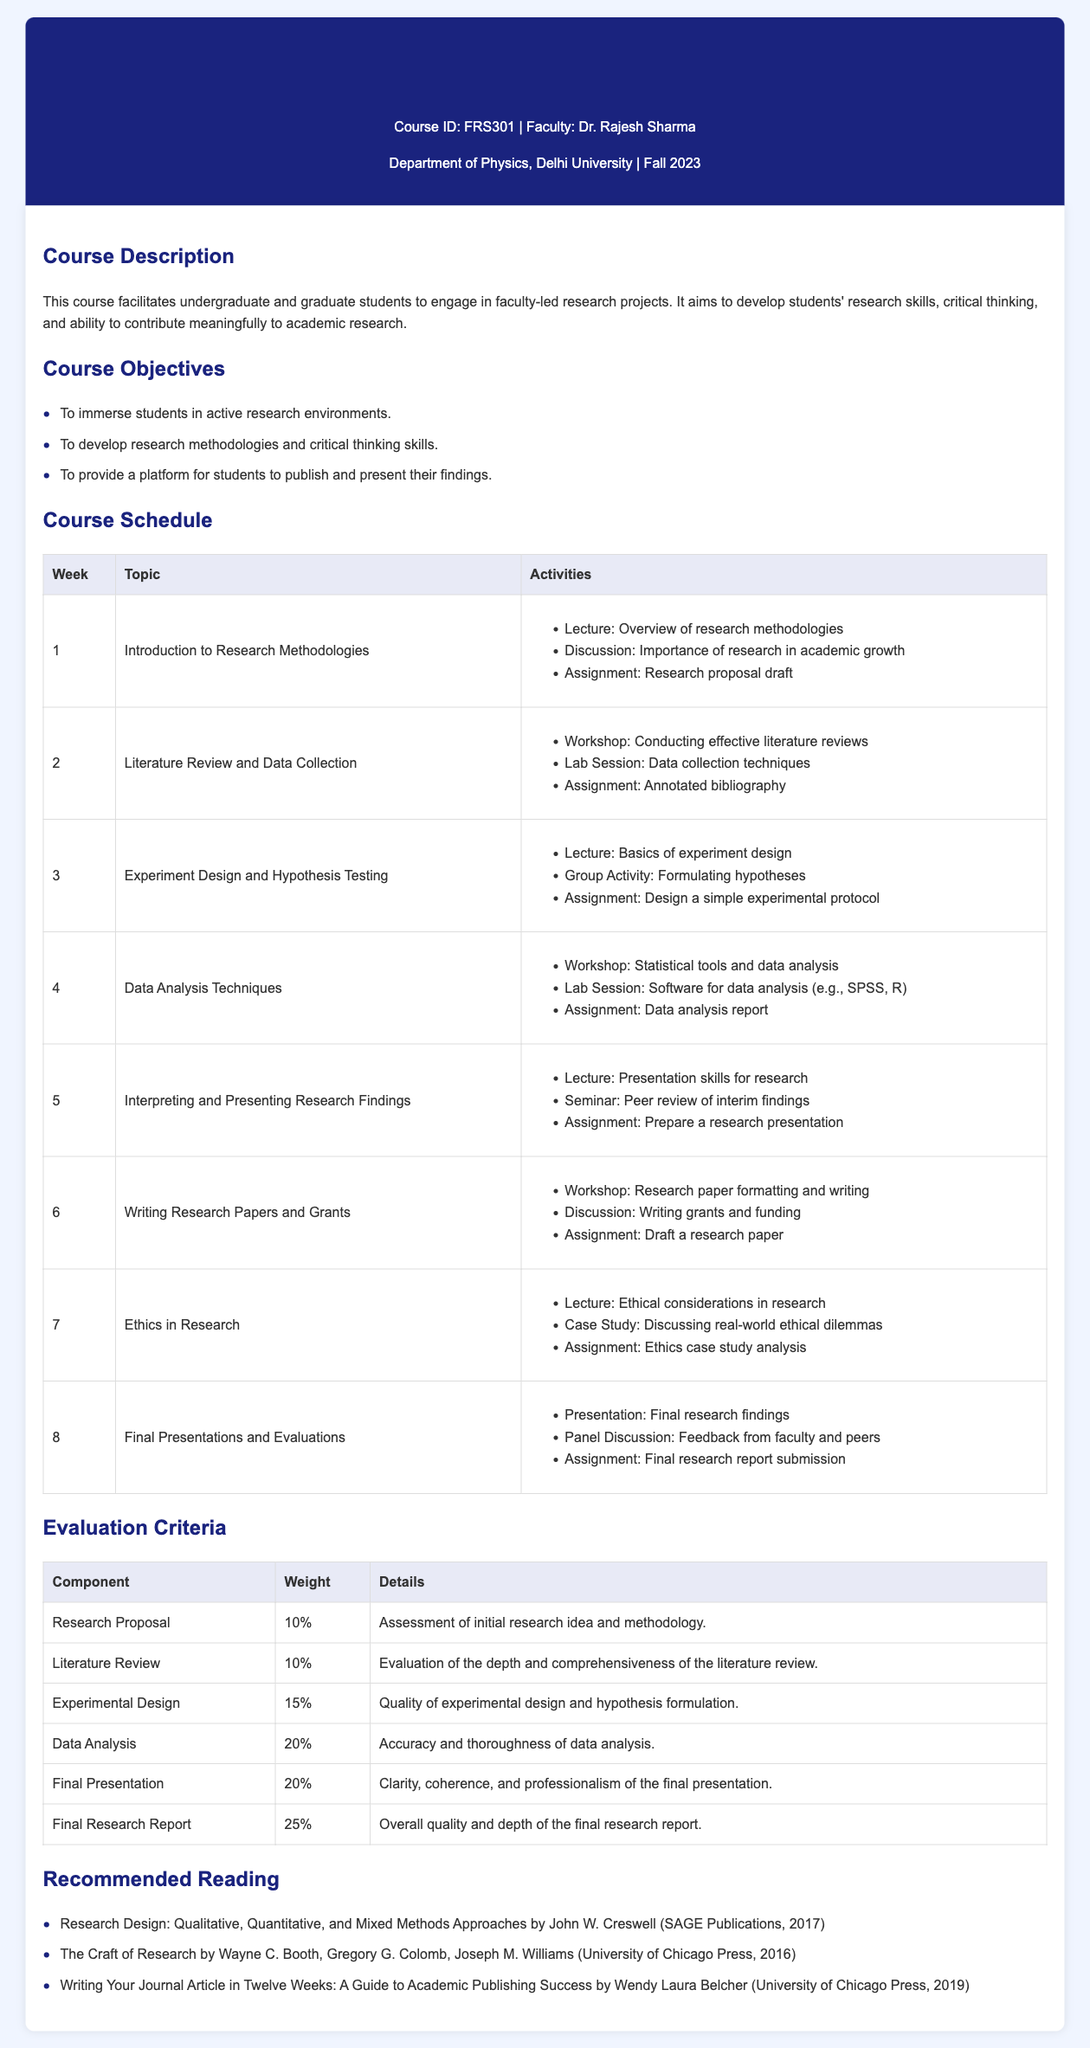What is the course ID? The course ID is mentioned at the beginning of the document.
Answer: FRS301 Who is the faculty for this course? The faculty is identified in the course details section of the document.
Answer: Dr. Rajesh Sharma What percentage of the final evaluation is based on the final research report? The evaluation table specifies the weight for each component.
Answer: 25% What is the title of the recommended reading by John W. Creswell? The recommended readings section lists the titles and authors of suggested materials.
Answer: Research Design: Qualitative, Quantitative, and Mixed Methods Approaches What is the focus of Week 5 in the course schedule? The schedule outlines the topic and activities for each week.
Answer: Interpreting and Presenting Research Findings Which component has the highest weight in the evaluation criteria? Observing the evaluation table allows for identification of the highest-weighted component.
Answer: Final Research Report What activity is included in Week 3 of the course schedule? The course schedule lists activities for each week.
Answer: Group Activity: Formulating hypotheses What is the primary aim of the course? The course description highlights the overall goal of the course.
Answer: Develop students' research skills, critical thinking, and ability to contribute meaningfully to academic research 